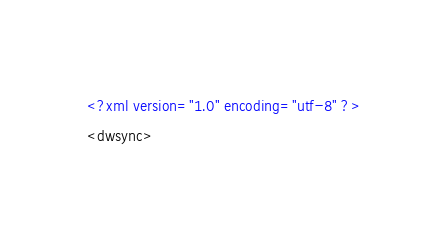<code> <loc_0><loc_0><loc_500><loc_500><_XML_><?xml version="1.0" encoding="utf-8" ?>
<dwsync></code> 